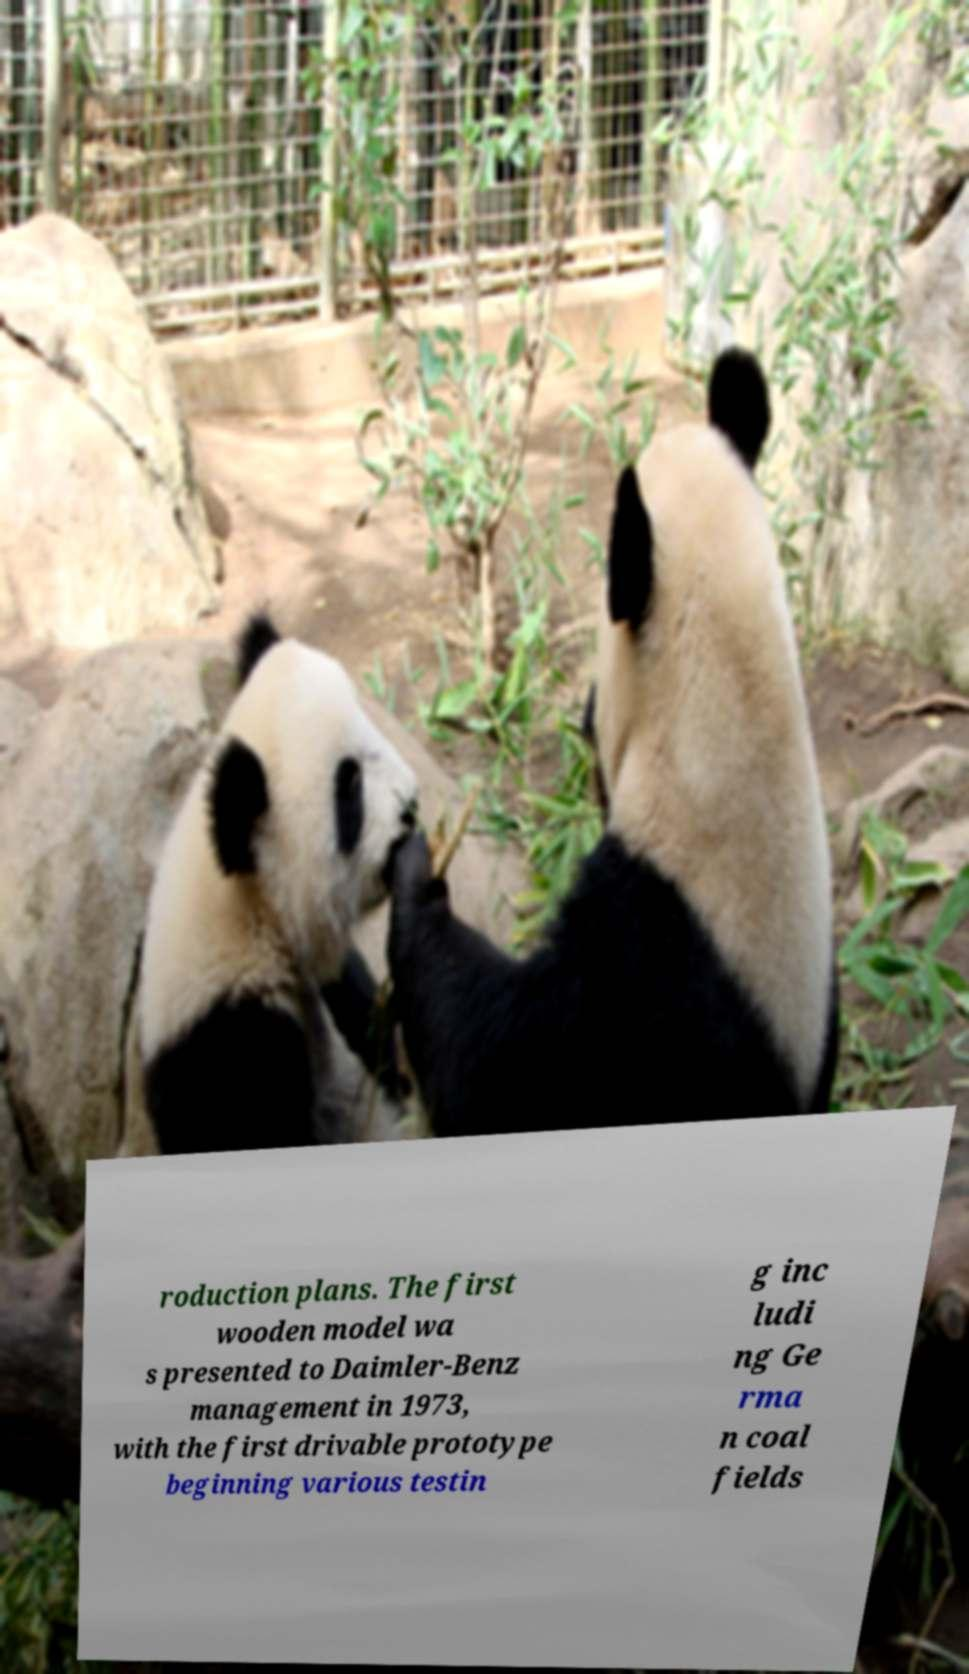There's text embedded in this image that I need extracted. Can you transcribe it verbatim? roduction plans. The first wooden model wa s presented to Daimler-Benz management in 1973, with the first drivable prototype beginning various testin g inc ludi ng Ge rma n coal fields 